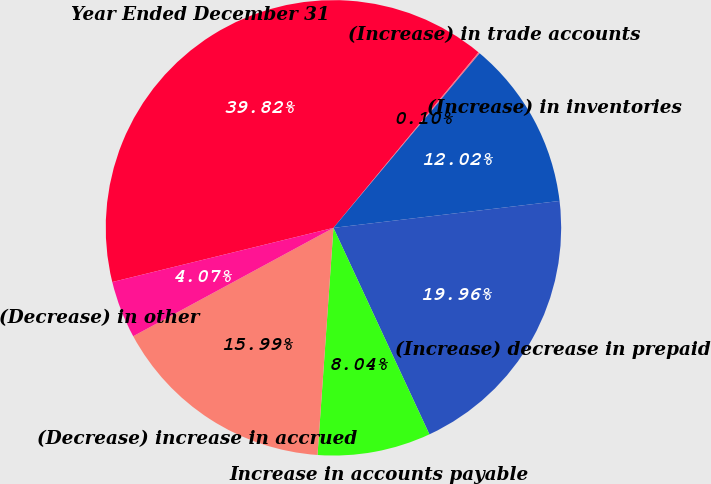<chart> <loc_0><loc_0><loc_500><loc_500><pie_chart><fcel>Year Ended December 31<fcel>(Increase) in trade accounts<fcel>(Increase) in inventories<fcel>(Increase) decrease in prepaid<fcel>Increase in accounts payable<fcel>(Decrease) increase in accrued<fcel>(Decrease) in other<nl><fcel>39.82%<fcel>0.1%<fcel>12.02%<fcel>19.96%<fcel>8.04%<fcel>15.99%<fcel>4.07%<nl></chart> 